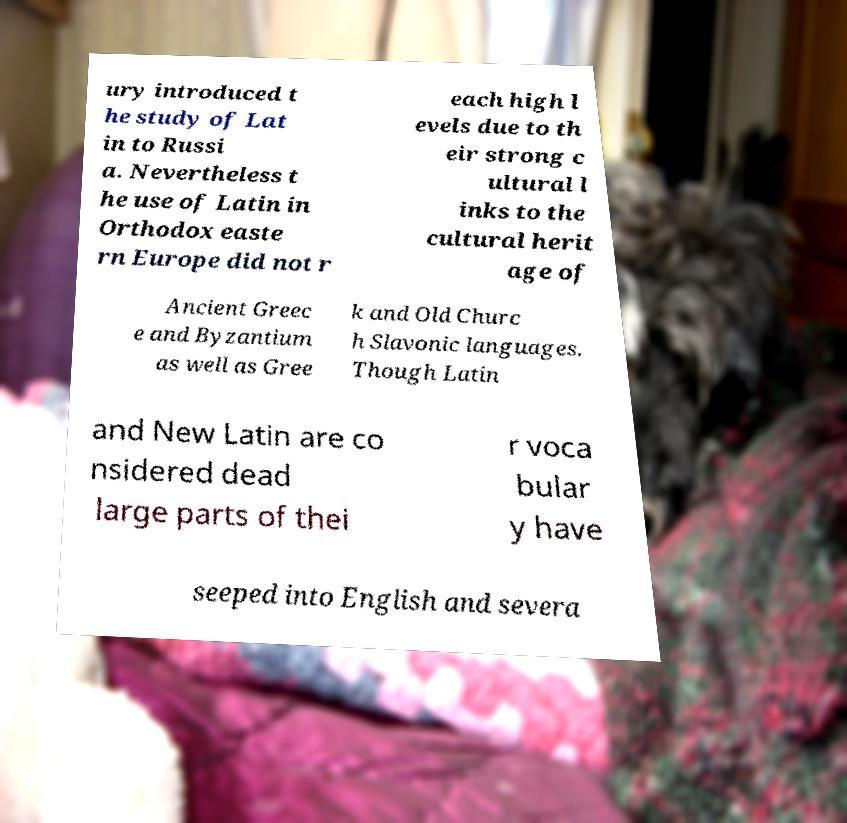There's text embedded in this image that I need extracted. Can you transcribe it verbatim? ury introduced t he study of Lat in to Russi a. Nevertheless t he use of Latin in Orthodox easte rn Europe did not r each high l evels due to th eir strong c ultural l inks to the cultural herit age of Ancient Greec e and Byzantium as well as Gree k and Old Churc h Slavonic languages. Though Latin and New Latin are co nsidered dead large parts of thei r voca bular y have seeped into English and severa 